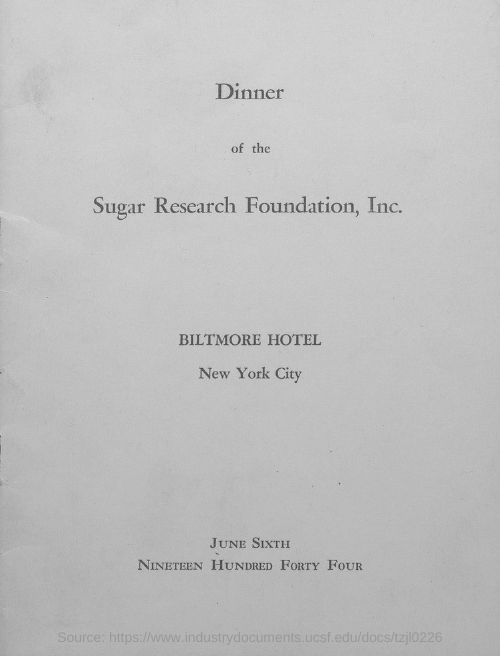Where is the dinner of the Sugar Research Foundation, Inc. organized?
Provide a short and direct response. Biltmore Hotel. When is the dinner of the Sugar Research Foundation, Inc. organized?
Your answer should be very brief. JUNE SIXTH, NINETEEN HUNDRED FORTY FOUR. 